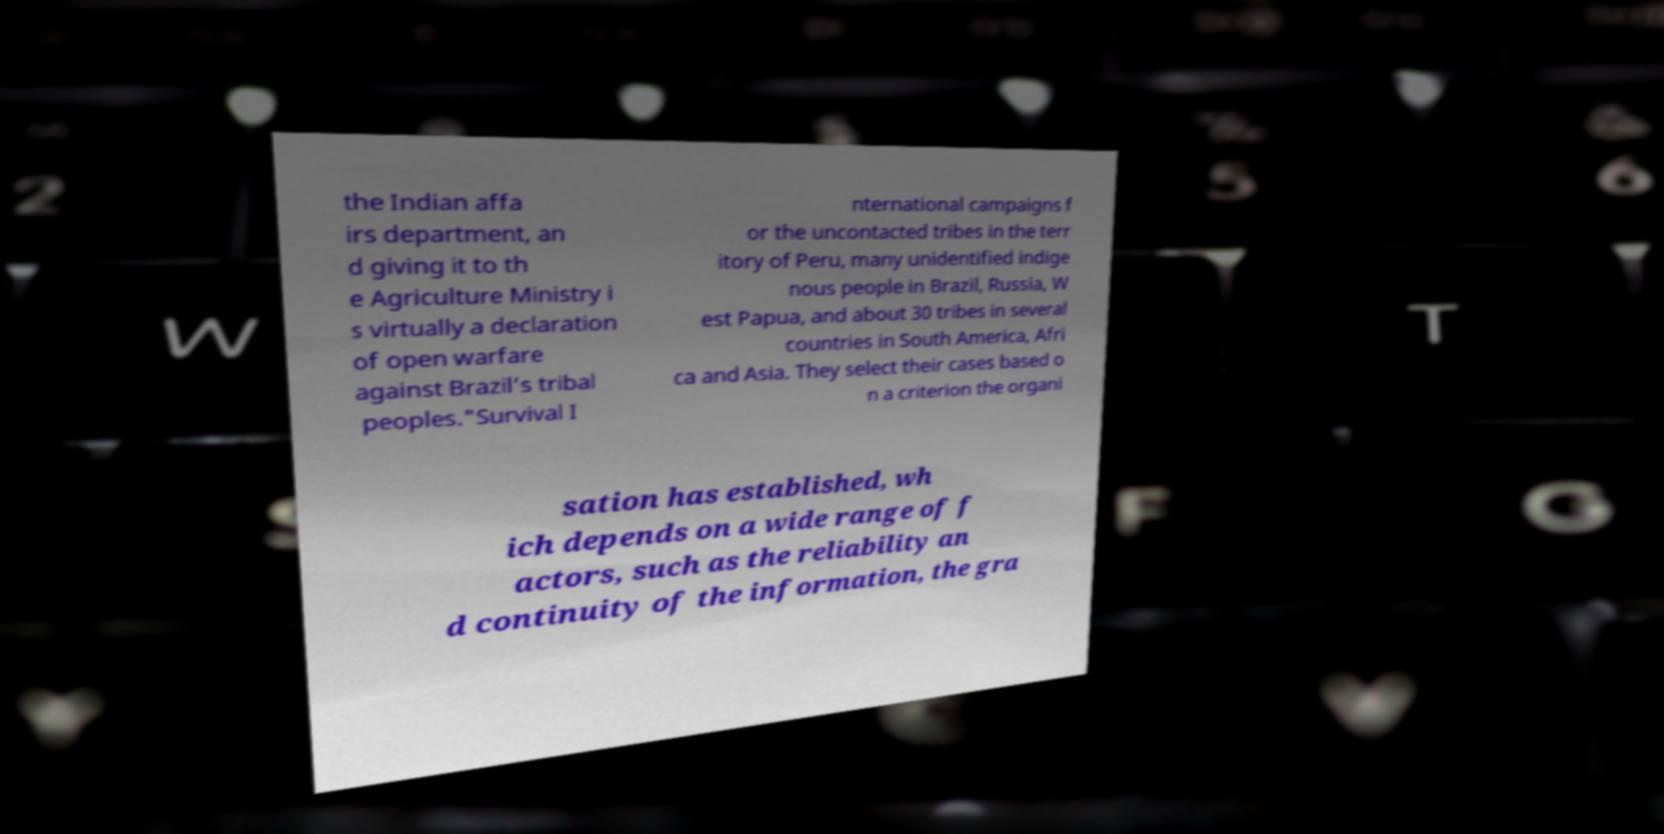I need the written content from this picture converted into text. Can you do that? the Indian affa irs department, an d giving it to th e Agriculture Ministry i s virtually a declaration of open warfare against Brazil’s tribal peoples."Survival I nternational campaigns f or the uncontacted tribes in the terr itory of Peru, many unidentified indige nous people in Brazil, Russia, W est Papua, and about 30 tribes in several countries in South America, Afri ca and Asia. They select their cases based o n a criterion the organi sation has established, wh ich depends on a wide range of f actors, such as the reliability an d continuity of the information, the gra 